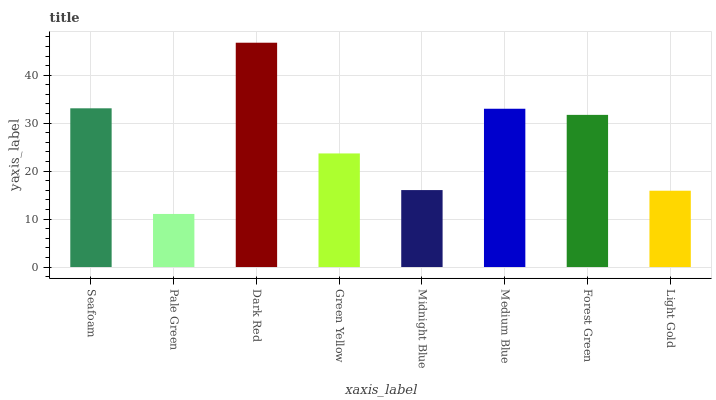Is Pale Green the minimum?
Answer yes or no. Yes. Is Dark Red the maximum?
Answer yes or no. Yes. Is Dark Red the minimum?
Answer yes or no. No. Is Pale Green the maximum?
Answer yes or no. No. Is Dark Red greater than Pale Green?
Answer yes or no. Yes. Is Pale Green less than Dark Red?
Answer yes or no. Yes. Is Pale Green greater than Dark Red?
Answer yes or no. No. Is Dark Red less than Pale Green?
Answer yes or no. No. Is Forest Green the high median?
Answer yes or no. Yes. Is Green Yellow the low median?
Answer yes or no. Yes. Is Seafoam the high median?
Answer yes or no. No. Is Midnight Blue the low median?
Answer yes or no. No. 